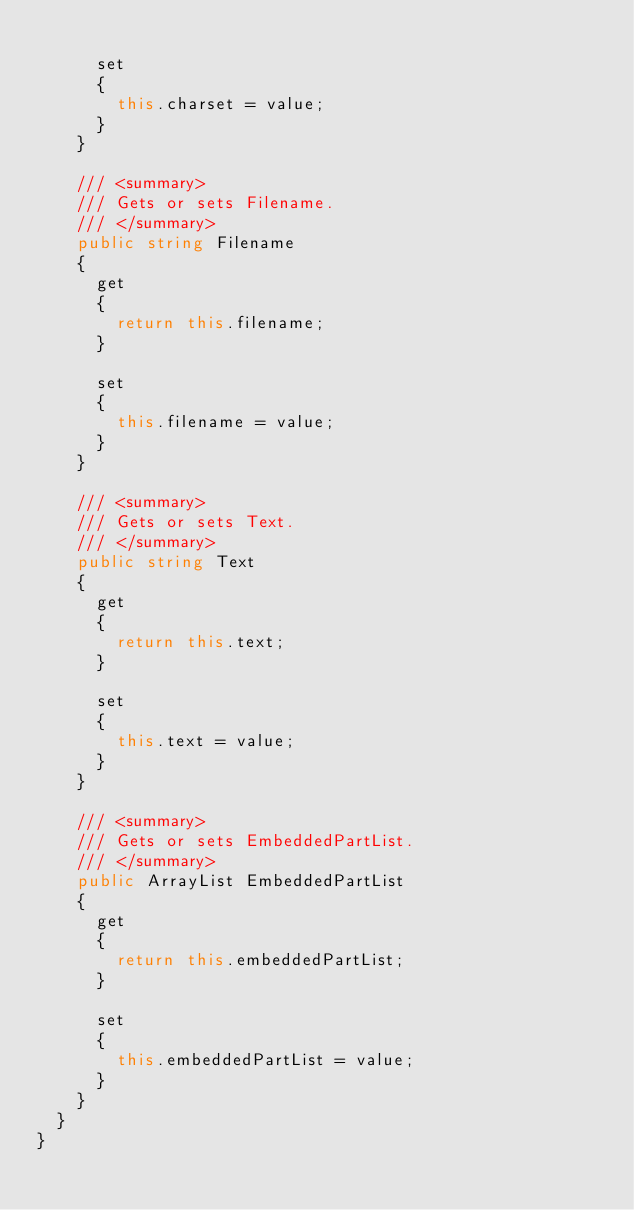Convert code to text. <code><loc_0><loc_0><loc_500><loc_500><_C#_>
      set
      {
        this.charset = value;
      }
    }

    /// <summary>
    /// Gets or sets Filename.
    /// </summary>
    public string Filename
    {
      get
      {
        return this.filename;
      }

      set
      {
        this.filename = value;
      }
    }

    /// <summary>
    /// Gets or sets Text.
    /// </summary>
    public string Text
    {
      get
      {
        return this.text;
      }

      set
      {
        this.text = value;
      }
    }

    /// <summary>
    /// Gets or sets EmbeddedPartList.
    /// </summary>
    public ArrayList EmbeddedPartList
    {
      get
      {
        return this.embeddedPartList;
      }

      set
      {
        this.embeddedPartList = value;
      }
    }
  }
}</code> 